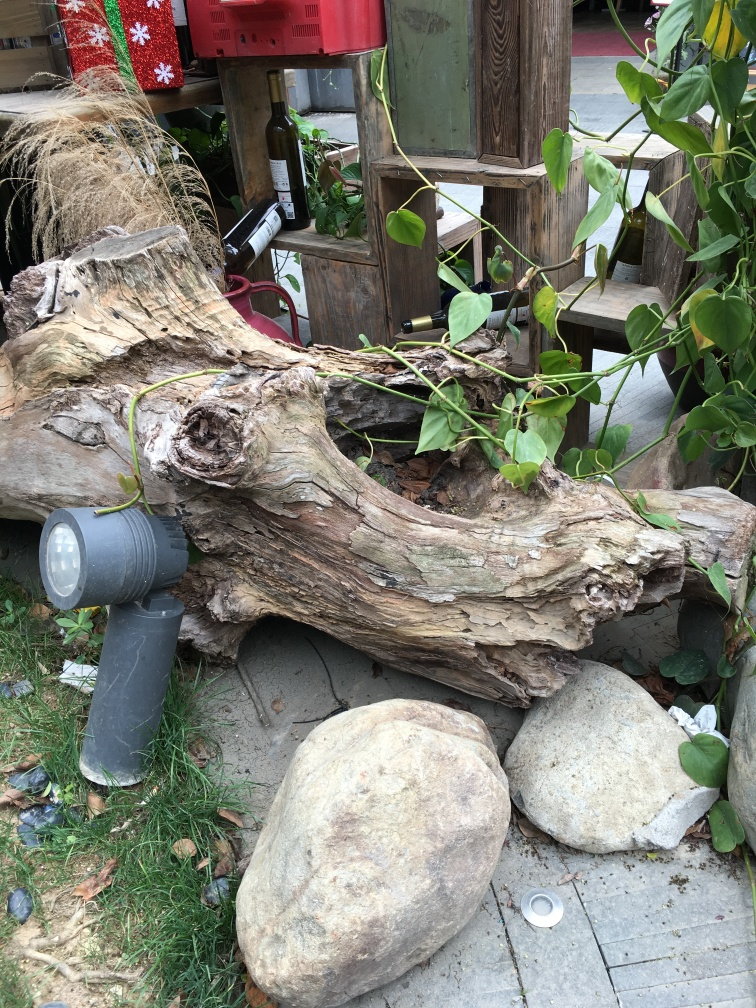Is the lighting unsure? It appears that the lighting in the photo is adequate for visibility, with shadows indicating a source of light coming from the upper left, although the specific conditions of the lighting cannot be determined with certainty. 